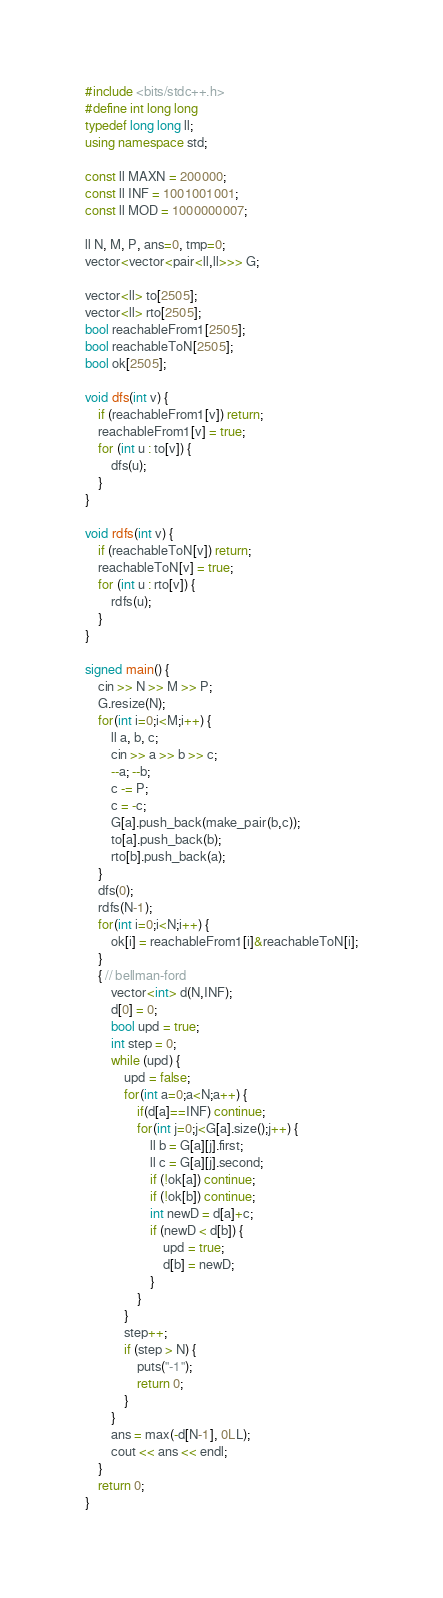<code> <loc_0><loc_0><loc_500><loc_500><_C++_>#include <bits/stdc++.h>
#define int long long
typedef long long ll;
using namespace std;

const ll MAXN = 200000;
const ll INF = 1001001001;
const ll MOD = 1000000007;

ll N, M, P, ans=0, tmp=0;
vector<vector<pair<ll,ll>>> G;

vector<ll> to[2505];
vector<ll> rto[2505];
bool reachableFrom1[2505];
bool reachableToN[2505];
bool ok[2505];
 
void dfs(int v) {
    if (reachableFrom1[v]) return;
    reachableFrom1[v] = true;
    for (int u : to[v]) {
        dfs(u);
    }
}

void rdfs(int v) {
    if (reachableToN[v]) return;
    reachableToN[v] = true;
    for (int u : rto[v]) {
        rdfs(u);
    }
}
 
signed main() {
    cin >> N >> M >> P;
    G.resize(N);
    for(int i=0;i<M;i++) {
        ll a, b, c;
        cin >> a >> b >> c;
        --a; --b;
        c -= P;
        c = -c;
        G[a].push_back(make_pair(b,c));
        to[a].push_back(b);
        rto[b].push_back(a);
    }
    dfs(0);
    rdfs(N-1);
    for(int i=0;i<N;i++) {
        ok[i] = reachableFrom1[i]&reachableToN[i];
    }
    { // bellman-ford
        vector<int> d(N,INF);
        d[0] = 0;
        bool upd = true;
        int step = 0;
        while (upd) {
            upd = false;
            for(int a=0;a<N;a++) {
                if(d[a]==INF) continue;
                for(int j=0;j<G[a].size();j++) {
                    ll b = G[a][j].first;
                    ll c = G[a][j].second;
                    if (!ok[a]) continue;
                    if (!ok[b]) continue;
                    int newD = d[a]+c;
                    if (newD < d[b]) {
                        upd = true;
                        d[b] = newD;
                    }
                }
            }
            step++;
            if (step > N) {
                puts("-1");
                return 0;
            }
        }
        ans = max(-d[N-1], 0LL);
        cout << ans << endl;
    }
    return 0;
}</code> 